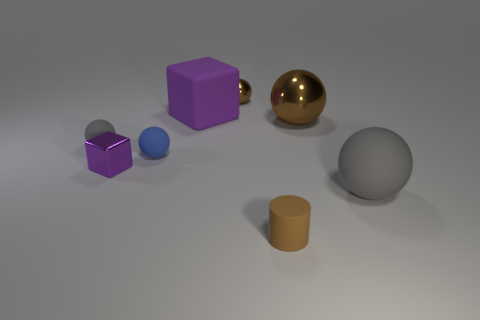Subtract 1 spheres. How many spheres are left? 4 Subtract all green spheres. Subtract all cyan cubes. How many spheres are left? 5 Add 1 metal balls. How many objects exist? 9 Subtract all balls. How many objects are left? 3 Add 7 brown rubber blocks. How many brown rubber blocks exist? 7 Subtract 0 gray cylinders. How many objects are left? 8 Subtract all brown metal blocks. Subtract all blue objects. How many objects are left? 7 Add 2 large blocks. How many large blocks are left? 3 